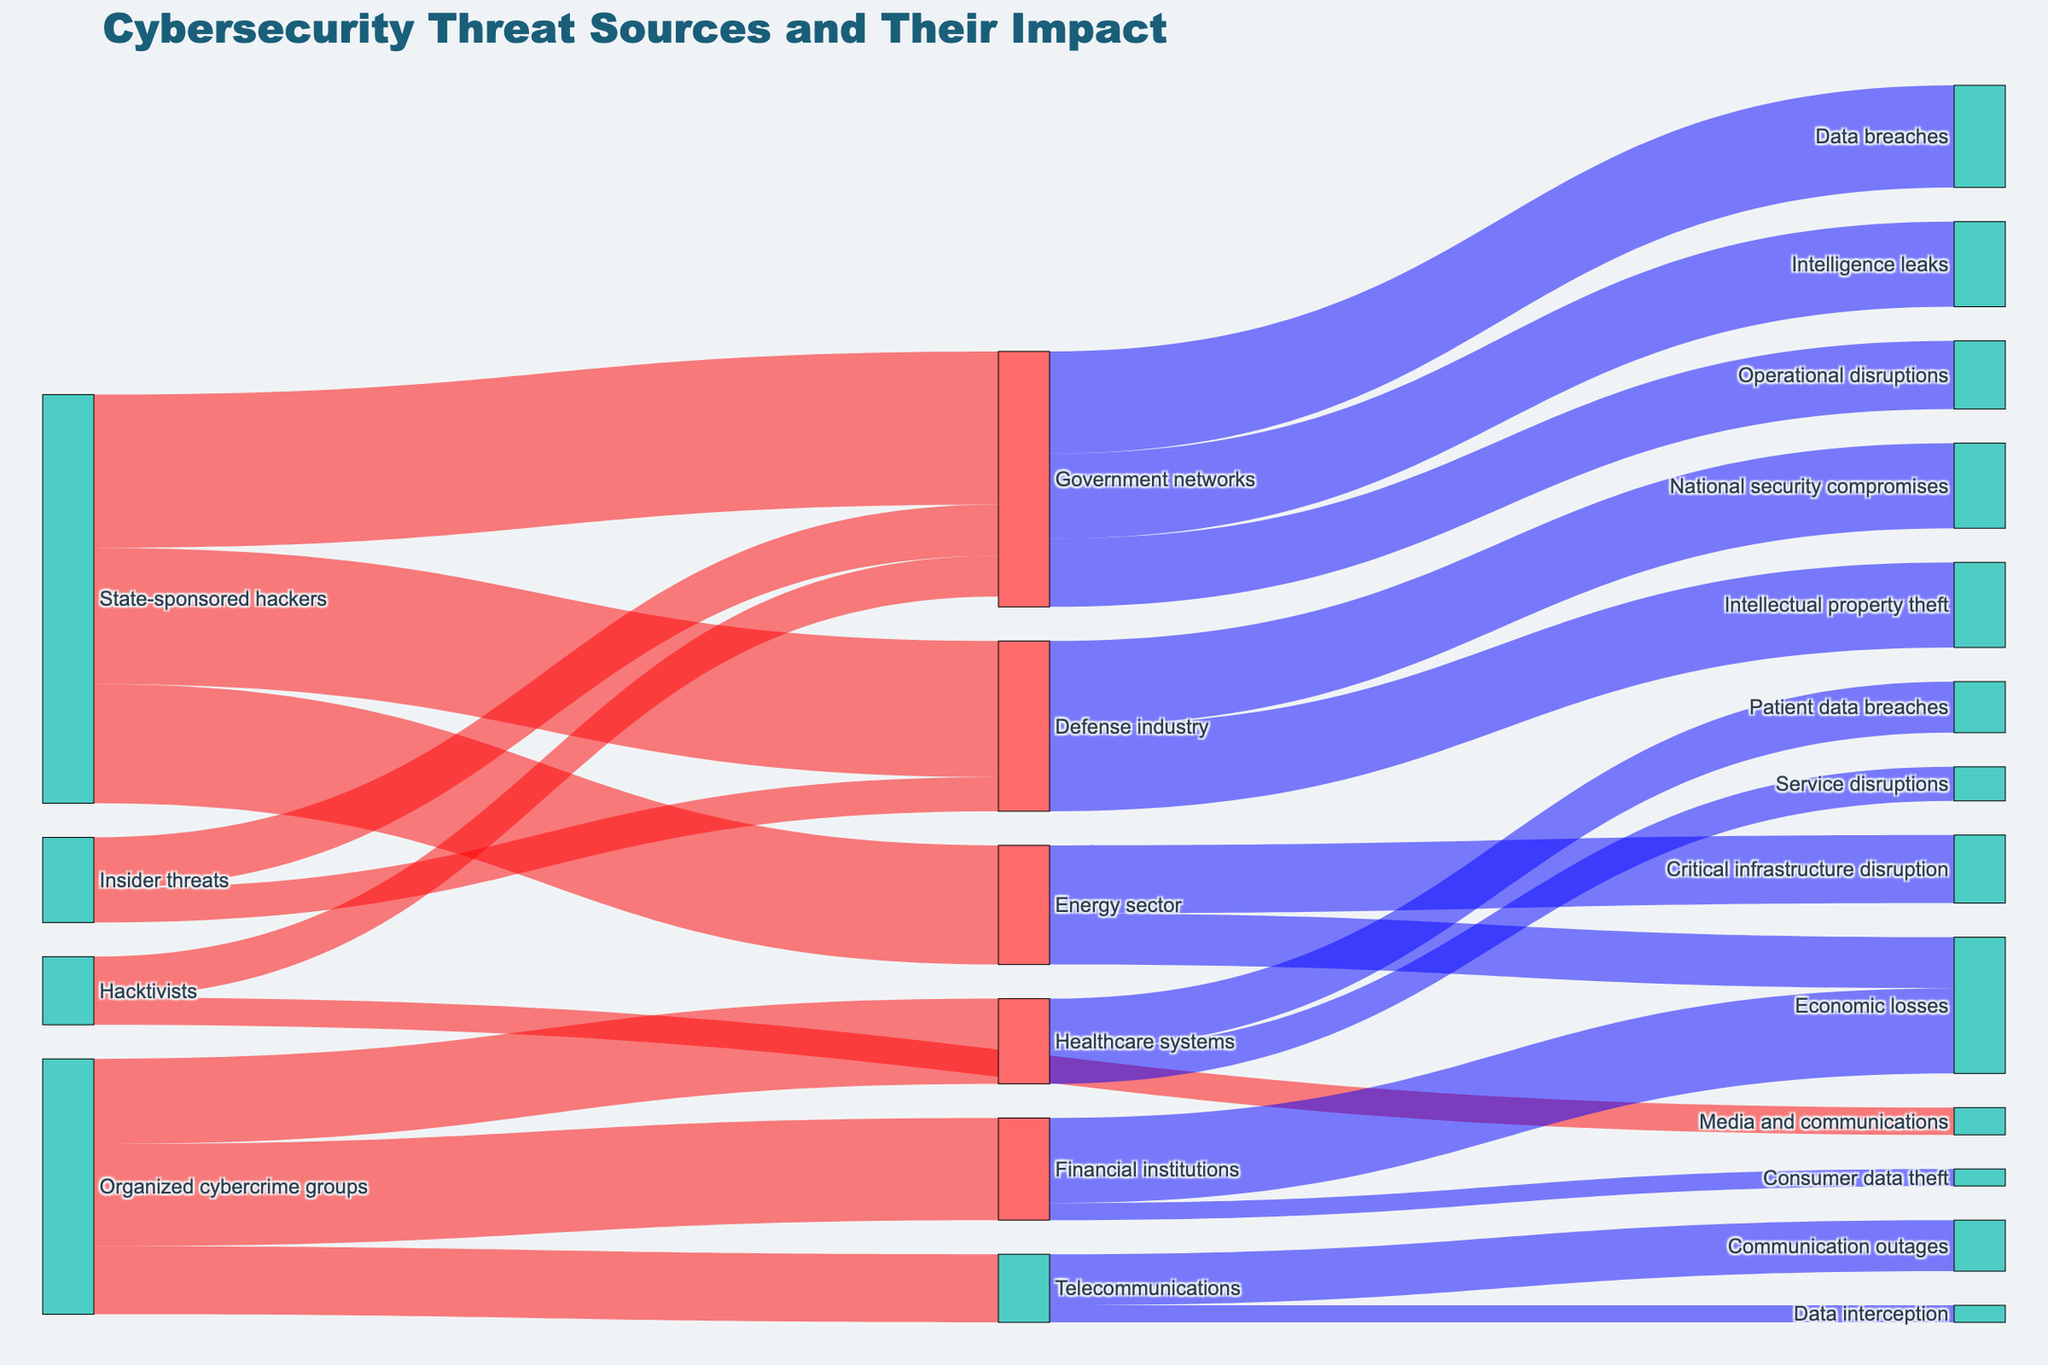What is the total value of impacts caused by State-sponsored hackers? The values affected by State-sponsored hackers are 35 (Energy sector), 40 (Defense industry), and 45 (Government networks). Adding them together: 35 + 40 + 45 = 120.
Answer: 120 Which threat source affects the Defense industry? The Defense industry is affected by two sources: State-sponsored hackers and Insider threats.
Answer: State-sponsored hackers, Insider threats What is the total value related to government network disruptions? Government network disruptions consist of values from State-sponsored hackers (45), Insider threats (15), hacktivists (12). Adding them together: 45 + 15 + 12 = 72.
Answer: 72 How do the values compare between impacts on Financial institutions and Government networks caused by Organized cybercrime groups? Organized cybercrime groups affect Financial institutions with a value of 30 and have no direct impact on Government networks. Organized cybercrime groups do not impact Government networks.
Answer: Financial institutions, 30; Government networks, 0 Which sector experiences the highest value of threat from Hacktivists? Hacktivists affect Media and communications (8) and Government networks (12). Government networks have the highest value.
Answer: Government networks What is the total economic loss caused by threats originating in the Energy sector? Economic losses due to threats in the Energy sector are valued at 15.
Answer: 15 Compare the values of Data breaches and Intelligence leaks impacting Government networks. Which one is higher? Data breaches in Government networks have a value of 30, while Intelligence leaks have a value of 25. Data breaches are higher.
Answer: Data breaches What is the single largest impact value shown in the diagram? The largest single impact value is 45, which is the impact of State-sponsored hackers on Government networks.
Answer: 45 What is the combined impact value on the Energy sector from various threat sources? The Energy sector is affected by State-sponsored hackers with a value of 35. There are no additional sources shown impacting the Energy sector in the diagram. The combined impact value is 35.
Answer: 35 Which sectors face impacts from Insider threats, and what are their values? Insider threats impact Government networks (15) and Defense industry (10).
Answer: Government networks, 15; Defense industry, 10 